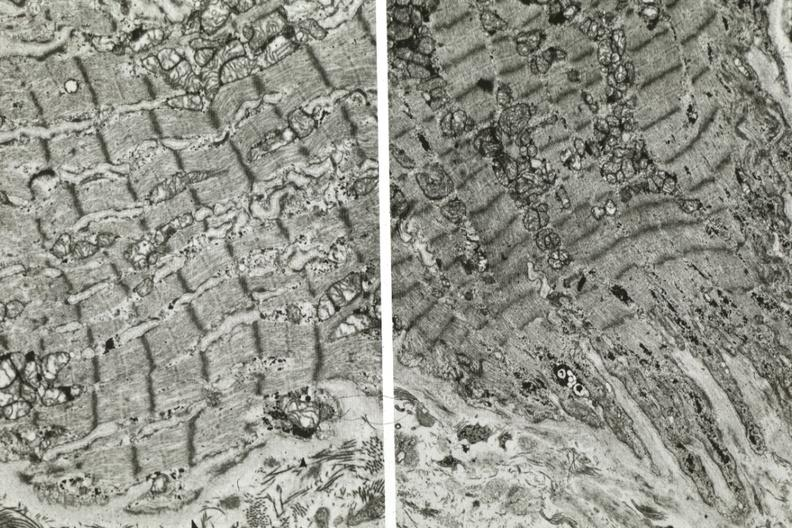does another fiber other frame show dilated sarcoplasmic reticulum?
Answer the question using a single word or phrase. Yes 